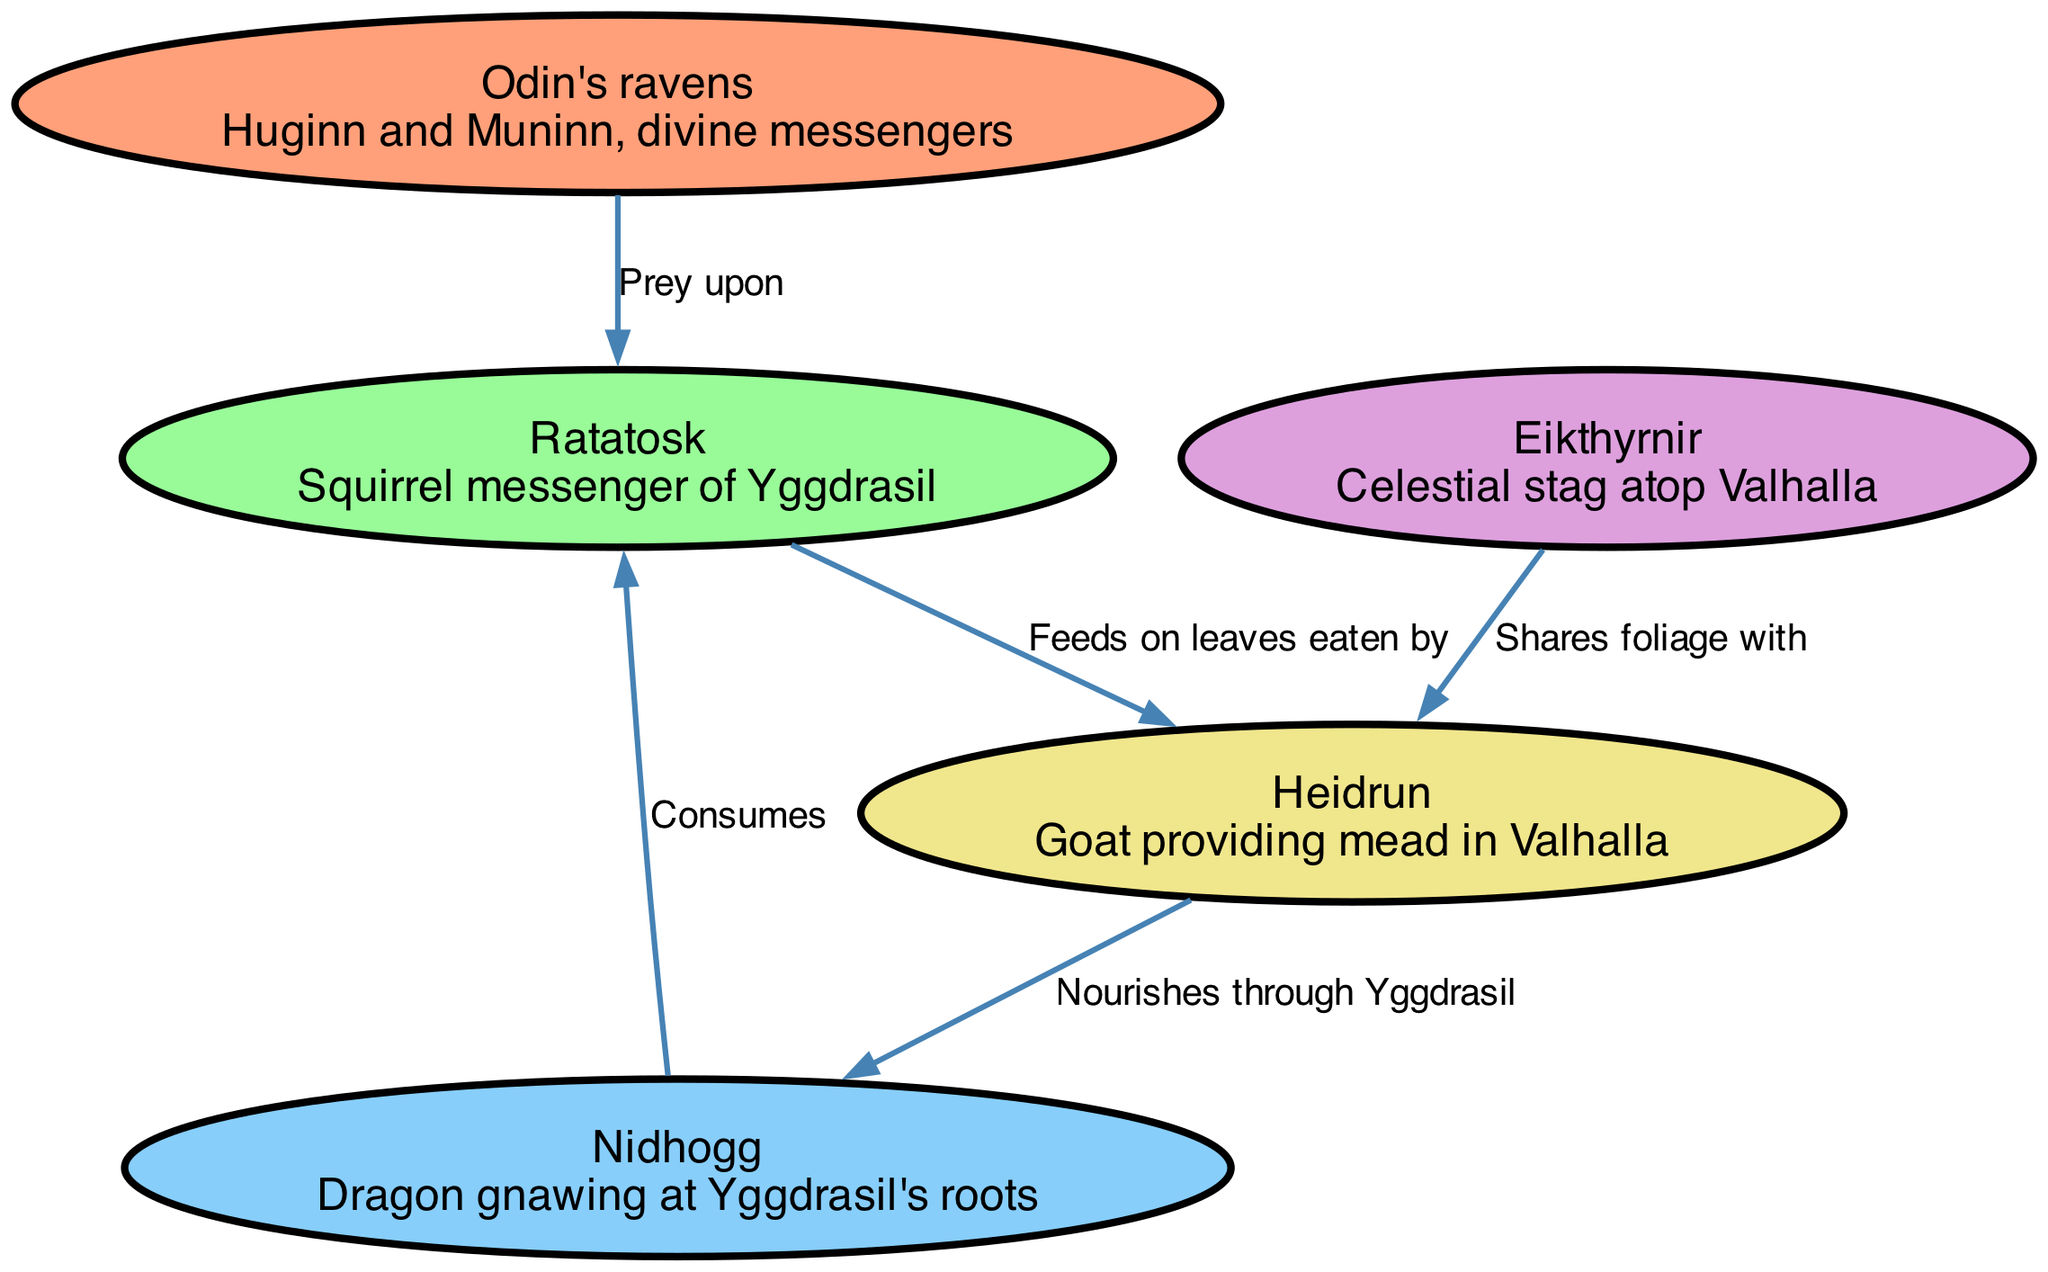What is the total number of nodes in the diagram? The diagram contains five distinct nodes: Odin's ravens, Ratatosk, Nidhogg, Eikthyrnir, and Heidrun. Therefore, the total number of nodes is counted as five.
Answer: 5 Who preys upon Ratatosk? According to the diagram, Odin's ravens are depicted as preying upon Ratatosk, as indicated by the labeled edge between these two nodes.
Answer: Odin's ravens Which creature shares foliage with Heidrun? The connection in the diagram shows Eikthyrnir sharing foliage with Heidrun, as represented by the edge labeled with "Shares foliage with."
Answer: Eikthyrnir What does Nidhogg consume? The diagram indicates that Nidhogg consumes Ratatosk, as reflected in the edge labeled "Consumes" leading to Ratatosk.
Answer: Ratatosk Which creature is at the base of the food chain that nourishes through Yggdrasil? The diagram illustrates that Heidrun nourishes Nidhogg through Yggdrasil, which establishes Heidrun's role at the base of this specific food chain.
Answer: Heidrun What is the relationship between Eikthyrnir and Heidrun? The relationship is depicted as sharing foliage, with an edge indicating that Eikthyrnir shares foliage with Heidrun, highlighting a connection between these two nodes.
Answer: Shares foliage with 